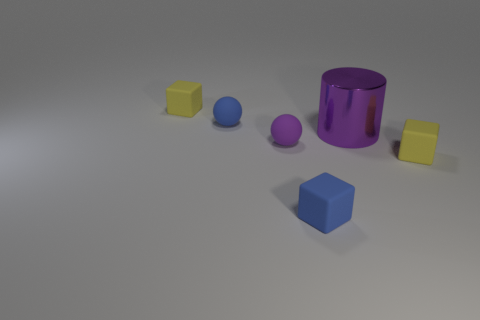What color is the tiny rubber cube that is to the left of the large purple metal thing and in front of the tiny purple ball?
Make the answer very short. Blue. There is a ball that is the same color as the large thing; what is its size?
Offer a terse response. Small. What is the shape of the tiny matte thing that is the same color as the large thing?
Offer a very short reply. Sphere. There is a yellow rubber thing in front of the block that is to the left of the tiny blue object in front of the tiny blue ball; what is its size?
Make the answer very short. Small. What is the small purple ball made of?
Offer a very short reply. Rubber. Is the small purple ball made of the same material as the yellow object that is to the right of the big purple metal object?
Offer a very short reply. Yes. Is there anything else that is the same color as the big metallic thing?
Ensure brevity in your answer.  Yes. Are there any large purple cylinders that are in front of the small yellow matte thing on the right side of the block that is to the left of the purple sphere?
Ensure brevity in your answer.  No. What is the color of the big cylinder?
Your answer should be compact. Purple. Are there any big objects left of the small blue sphere?
Provide a short and direct response. No. 